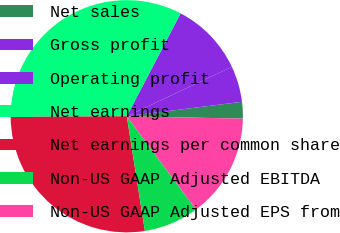<chart> <loc_0><loc_0><loc_500><loc_500><pie_chart><fcel>Net sales<fcel>Gross profit<fcel>Operating profit<fcel>Net earnings<fcel>Net earnings per common share<fcel>Non-US GAAP Adjusted EBITDA<fcel>Non-US GAAP Adjusted EPS from<nl><fcel>2.32%<fcel>5.0%<fcel>10.34%<fcel>32.76%<fcel>27.41%<fcel>7.67%<fcel>14.51%<nl></chart> 